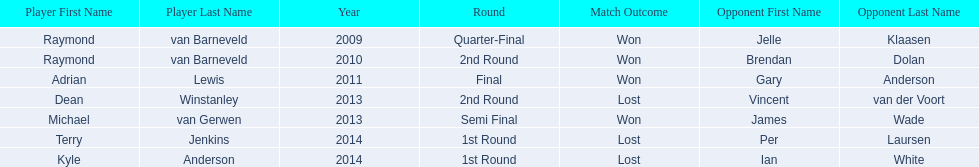Who are the players listed? Raymond van Barneveld, Raymond van Barneveld, Adrian Lewis, Dean Winstanley, Michael van Gerwen, Terry Jenkins, Kyle Anderson. Which of these players played in 2011? Adrian Lewis. 